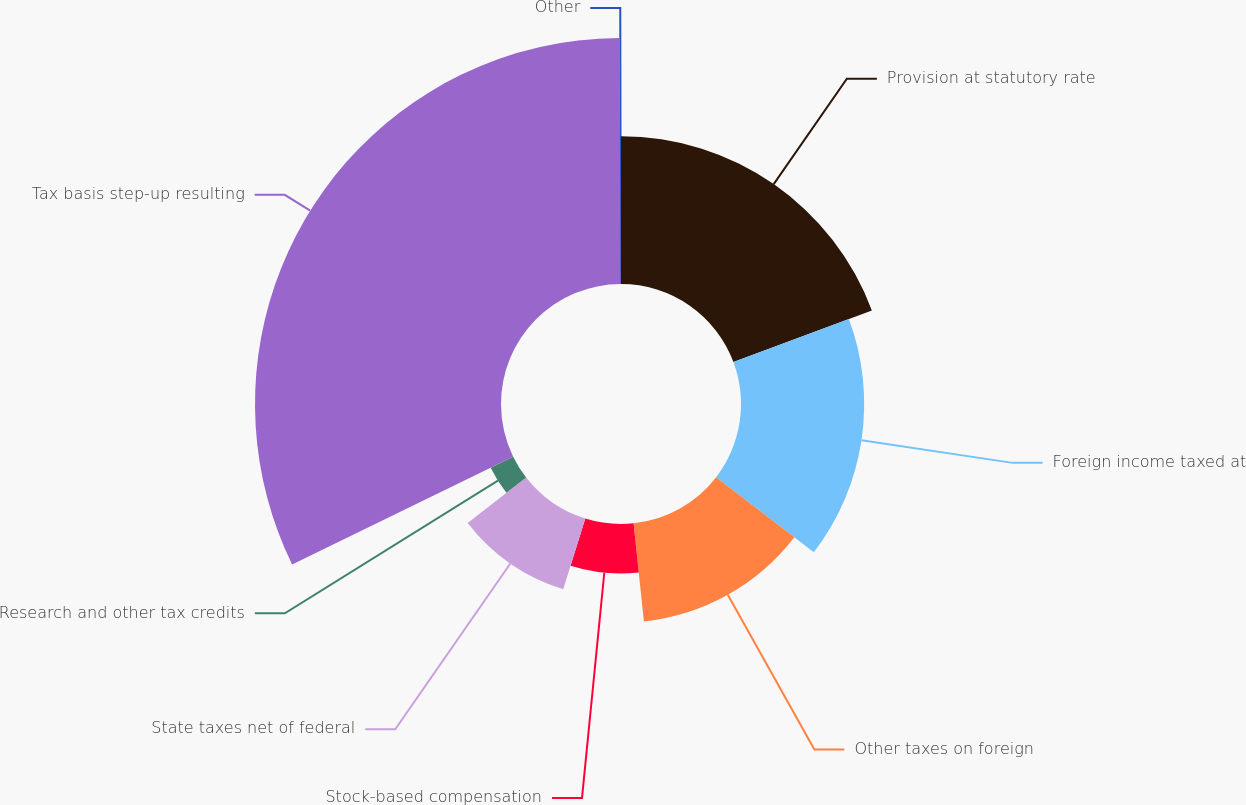Convert chart. <chart><loc_0><loc_0><loc_500><loc_500><pie_chart><fcel>Provision at statutory rate<fcel>Foreign income taxed at<fcel>Other taxes on foreign<fcel>Stock-based compensation<fcel>State taxes net of federal<fcel>Research and other tax credits<fcel>Tax basis step-up resulting<fcel>Other<nl><fcel>19.32%<fcel>16.11%<fcel>12.9%<fcel>6.48%<fcel>9.69%<fcel>3.27%<fcel>32.17%<fcel>0.06%<nl></chart> 